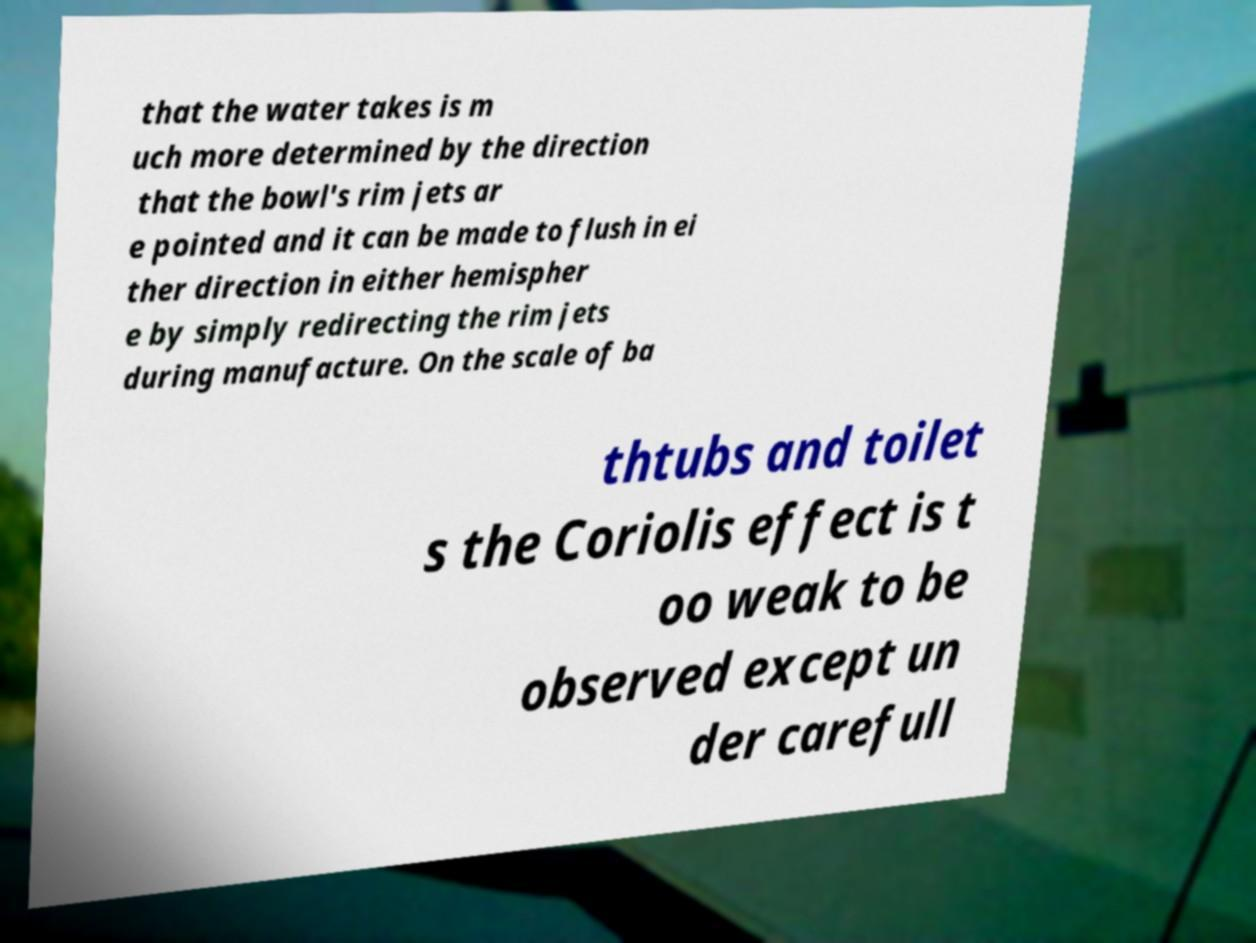I need the written content from this picture converted into text. Can you do that? that the water takes is m uch more determined by the direction that the bowl's rim jets ar e pointed and it can be made to flush in ei ther direction in either hemispher e by simply redirecting the rim jets during manufacture. On the scale of ba thtubs and toilet s the Coriolis effect is t oo weak to be observed except un der carefull 